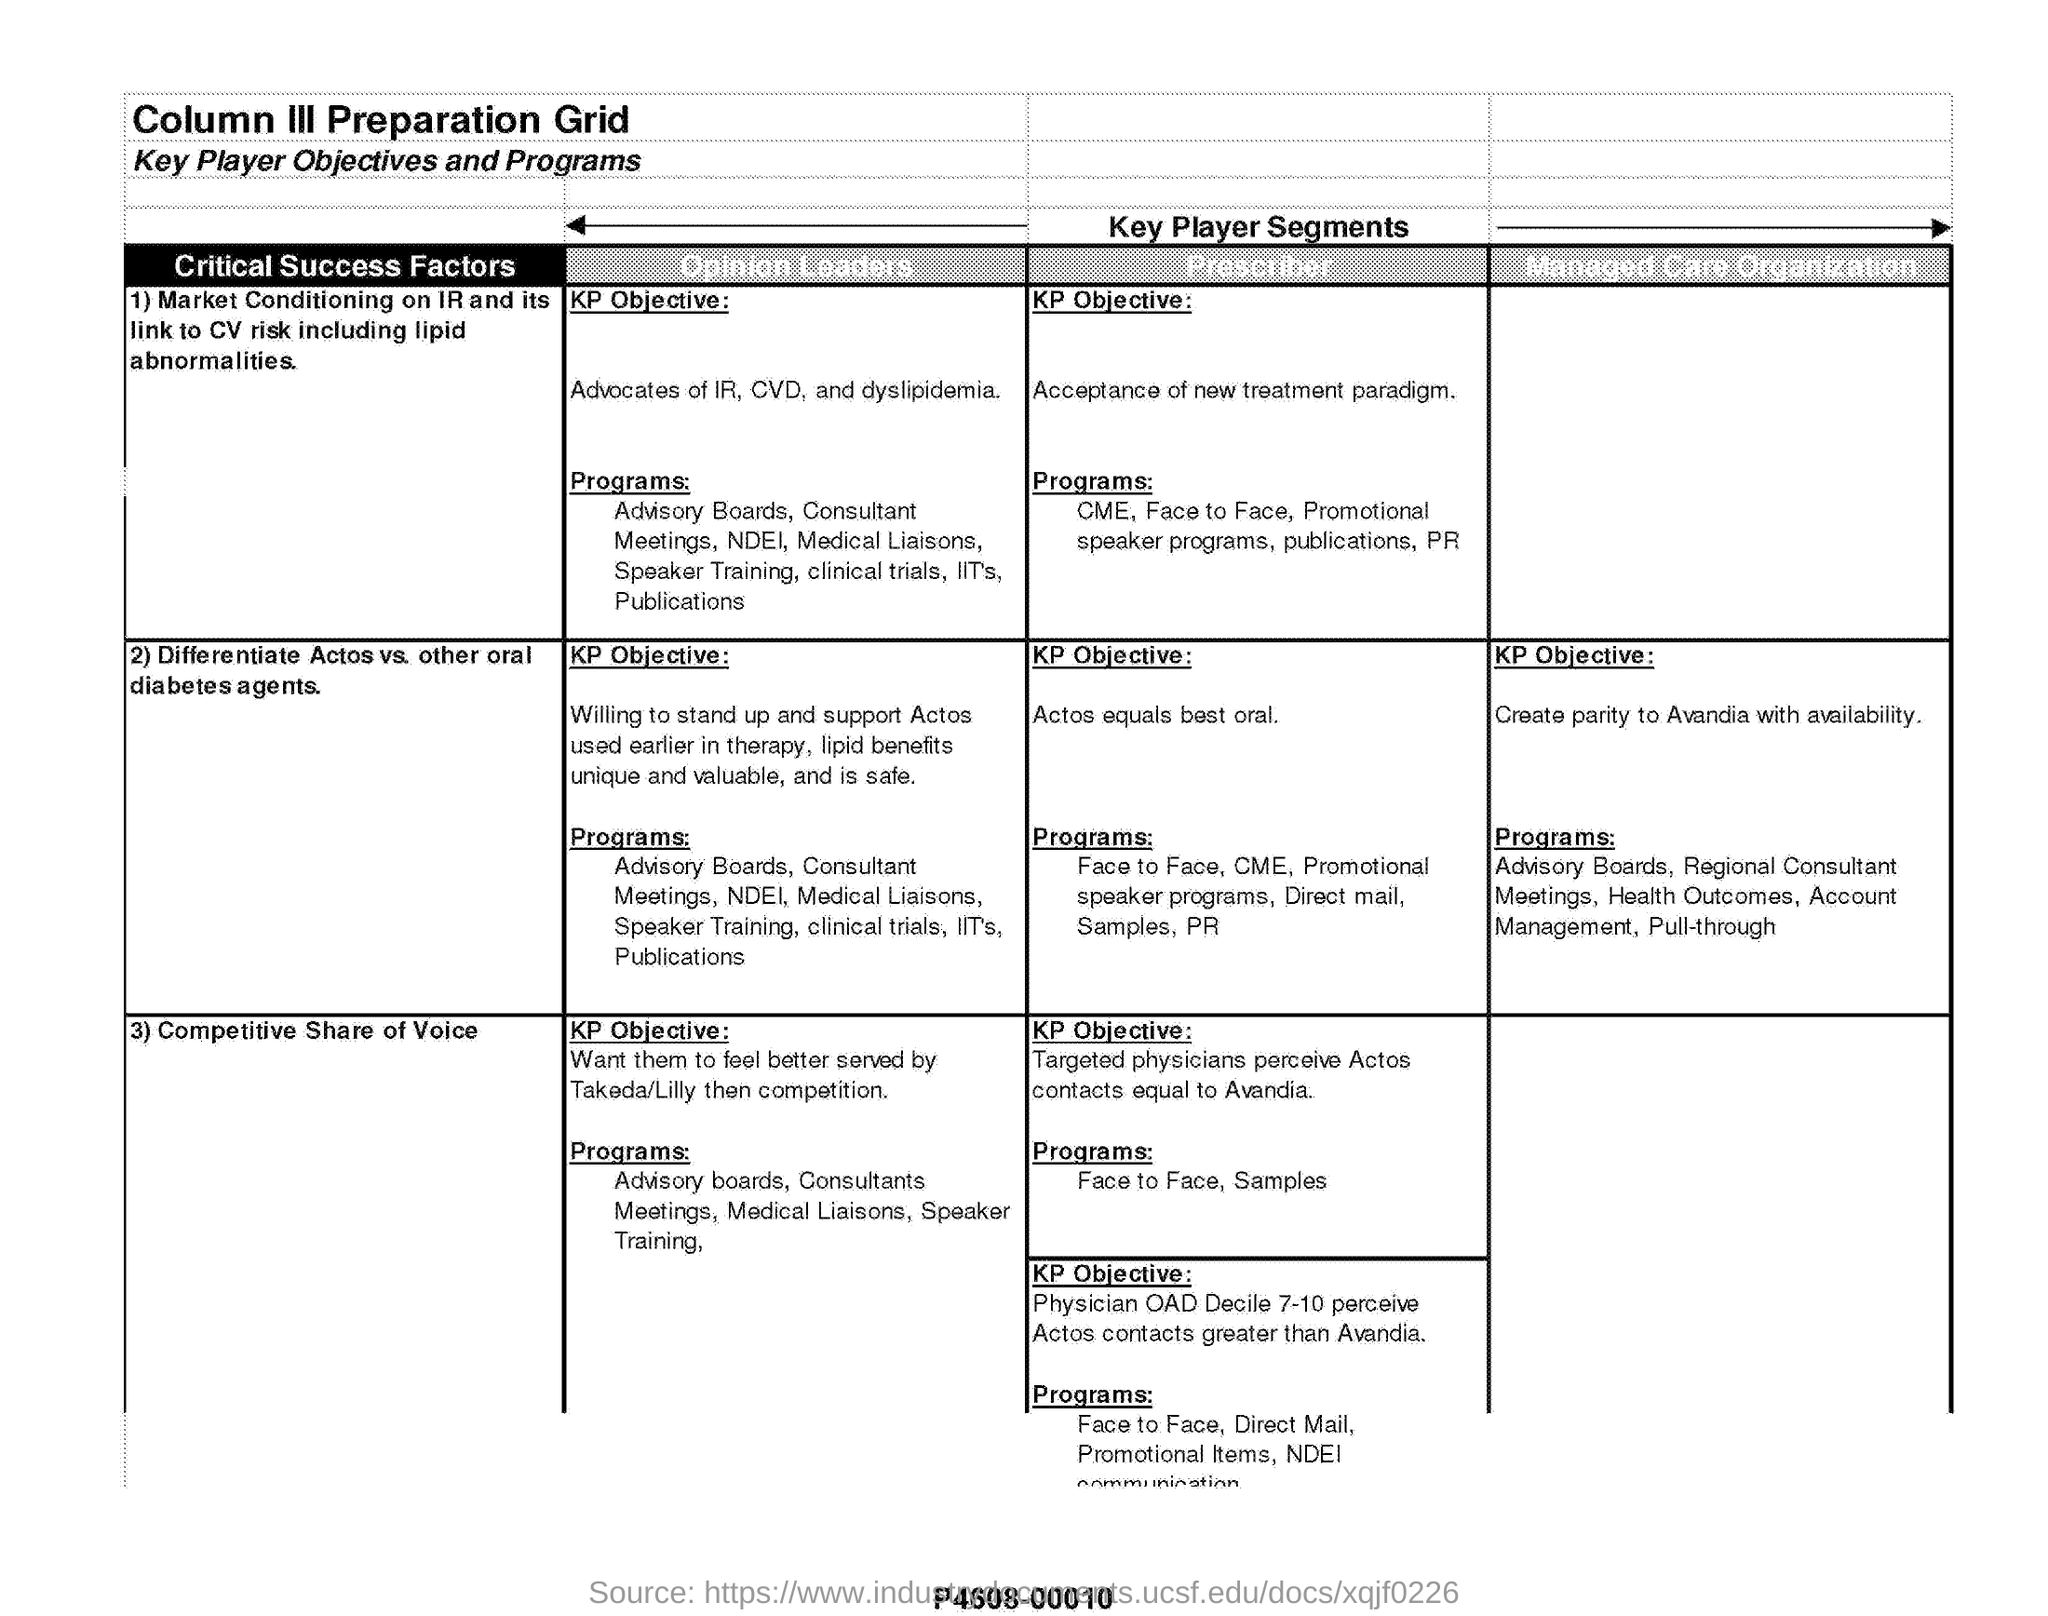Outline some significant characteristics in this image. Competitive Share of Voice is the third critical success factor listed in the document. The Key Player Segments section lists critical success factors for each category of players involved in the construction industry value chain. These factors serve as a guide for understanding the importance of each player's role in achieving the desired outcomes of the project. The KP objective for the success factor "Differentiate Actos vs. other oral diabetes agents" for the "Prescriber" is to ensure that ACTOS equals the best oral diabetes treatment option, thereby achieving the desired outcome. 